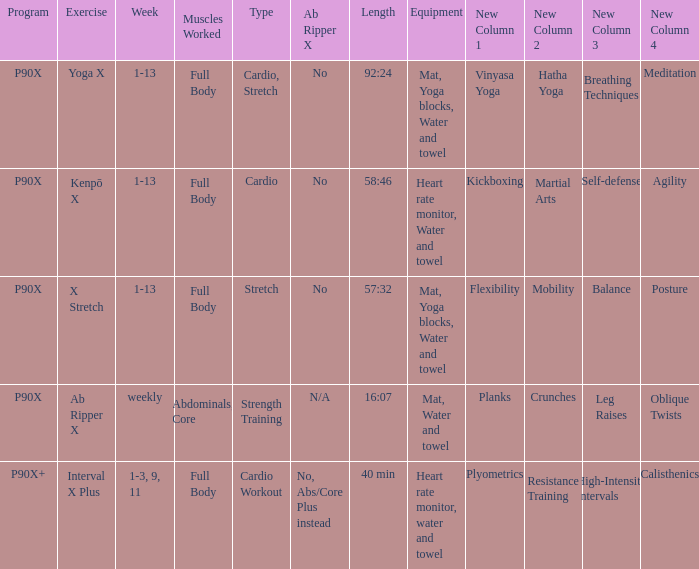During which week is the cardio workout type scheduled? 1-3, 9, 11. 